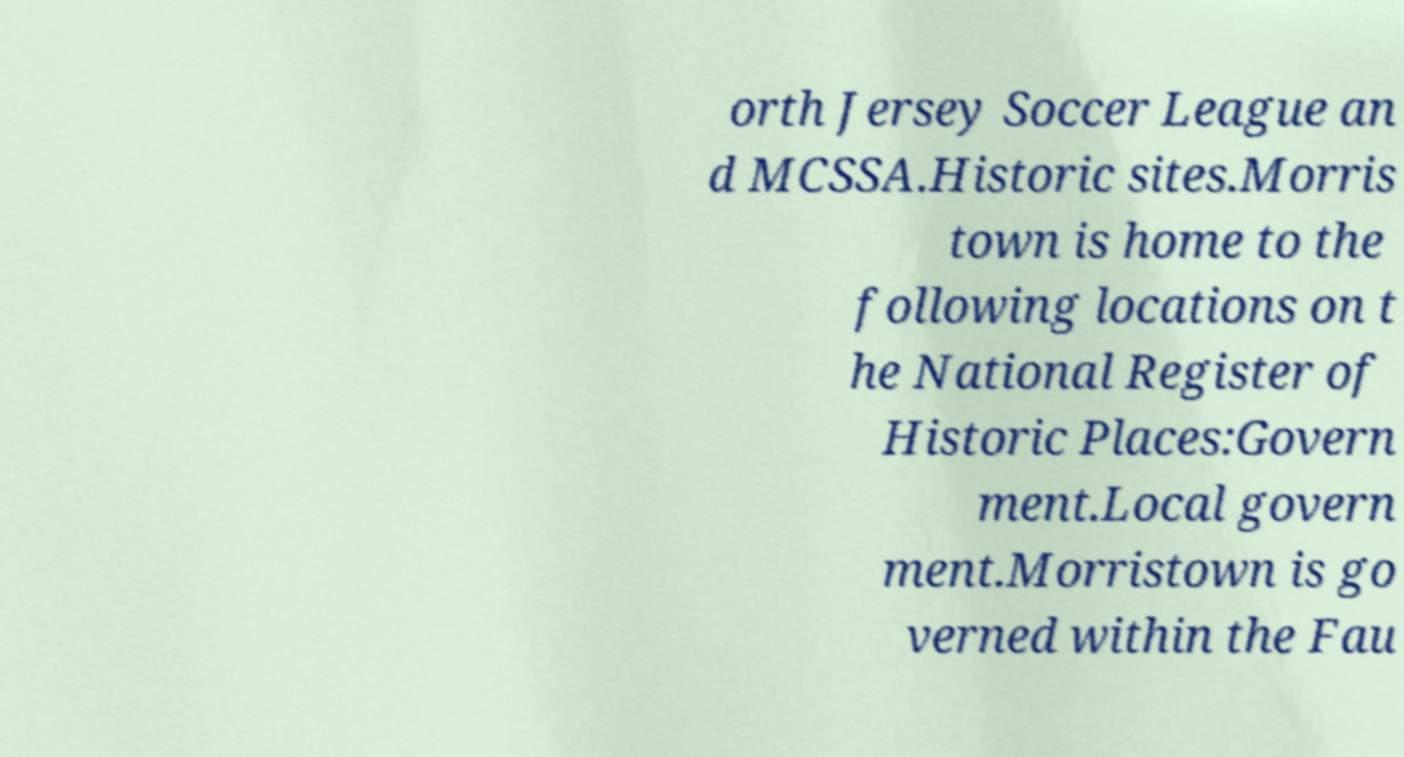I need the written content from this picture converted into text. Can you do that? orth Jersey Soccer League an d MCSSA.Historic sites.Morris town is home to the following locations on t he National Register of Historic Places:Govern ment.Local govern ment.Morristown is go verned within the Fau 